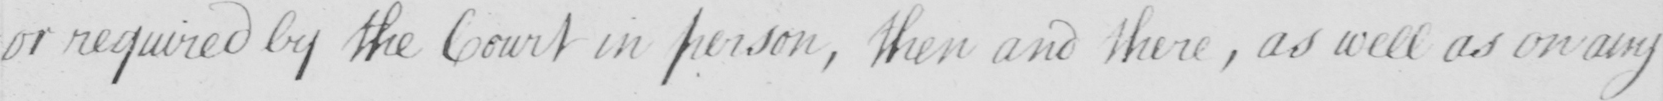What does this handwritten line say? or required by the Court in person , then and there  , as well as on any 